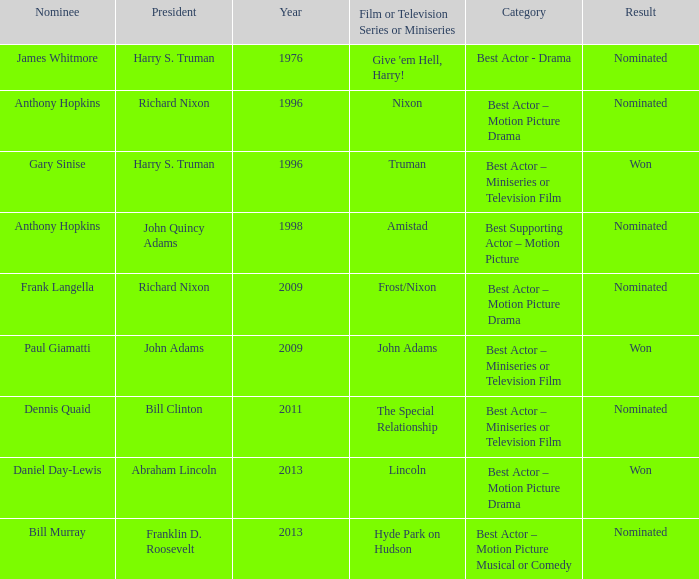Can you give me this table as a dict? {'header': ['Nominee', 'President', 'Year', 'Film or Television Series or Miniseries', 'Category', 'Result'], 'rows': [['James Whitmore', 'Harry S. Truman', '1976', "Give 'em Hell, Harry!", 'Best Actor - Drama', 'Nominated'], ['Anthony Hopkins', 'Richard Nixon', '1996', 'Nixon', 'Best Actor – Motion Picture Drama', 'Nominated'], ['Gary Sinise', 'Harry S. Truman', '1996', 'Truman', 'Best Actor – Miniseries or Television Film', 'Won'], ['Anthony Hopkins', 'John Quincy Adams', '1998', 'Amistad', 'Best Supporting Actor – Motion Picture', 'Nominated'], ['Frank Langella', 'Richard Nixon', '2009', 'Frost/Nixon', 'Best Actor – Motion Picture Drama', 'Nominated'], ['Paul Giamatti', 'John Adams', '2009', 'John Adams', 'Best Actor – Miniseries or Television Film', 'Won'], ['Dennis Quaid', 'Bill Clinton', '2011', 'The Special Relationship', 'Best Actor – Miniseries or Television Film', 'Nominated'], ['Daniel Day-Lewis', 'Abraham Lincoln', '2013', 'Lincoln', 'Best Actor – Motion Picture Drama', 'Won'], ['Bill Murray', 'Franklin D. Roosevelt', '2013', 'Hyde Park on Hudson', 'Best Actor – Motion Picture Musical or Comedy', 'Nominated']]} What was the result of Frank Langella? Nominated. 